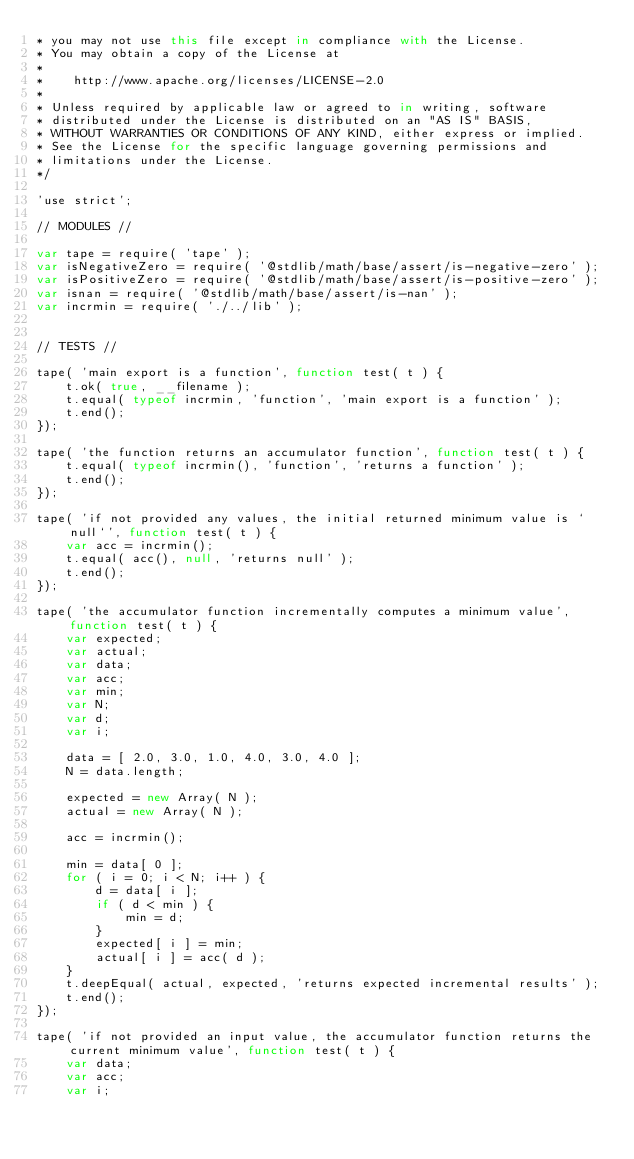<code> <loc_0><loc_0><loc_500><loc_500><_JavaScript_>* you may not use this file except in compliance with the License.
* You may obtain a copy of the License at
*
*    http://www.apache.org/licenses/LICENSE-2.0
*
* Unless required by applicable law or agreed to in writing, software
* distributed under the License is distributed on an "AS IS" BASIS,
* WITHOUT WARRANTIES OR CONDITIONS OF ANY KIND, either express or implied.
* See the License for the specific language governing permissions and
* limitations under the License.
*/

'use strict';

// MODULES //

var tape = require( 'tape' );
var isNegativeZero = require( '@stdlib/math/base/assert/is-negative-zero' );
var isPositiveZero = require( '@stdlib/math/base/assert/is-positive-zero' );
var isnan = require( '@stdlib/math/base/assert/is-nan' );
var incrmin = require( './../lib' );


// TESTS //

tape( 'main export is a function', function test( t ) {
	t.ok( true, __filename );
	t.equal( typeof incrmin, 'function', 'main export is a function' );
	t.end();
});

tape( 'the function returns an accumulator function', function test( t ) {
	t.equal( typeof incrmin(), 'function', 'returns a function' );
	t.end();
});

tape( 'if not provided any values, the initial returned minimum value is `null`', function test( t ) {
	var acc = incrmin();
	t.equal( acc(), null, 'returns null' );
	t.end();
});

tape( 'the accumulator function incrementally computes a minimum value', function test( t ) {
	var expected;
	var actual;
	var data;
	var acc;
	var min;
	var N;
	var d;
	var i;

	data = [ 2.0, 3.0, 1.0, 4.0, 3.0, 4.0 ];
	N = data.length;

	expected = new Array( N );
	actual = new Array( N );

	acc = incrmin();

	min = data[ 0 ];
	for ( i = 0; i < N; i++ ) {
		d = data[ i ];
		if ( d < min ) {
			min = d;
		}
		expected[ i ] = min;
		actual[ i ] = acc( d );
	}
	t.deepEqual( actual, expected, 'returns expected incremental results' );
	t.end();
});

tape( 'if not provided an input value, the accumulator function returns the current minimum value', function test( t ) {
	var data;
	var acc;
	var i;
</code> 